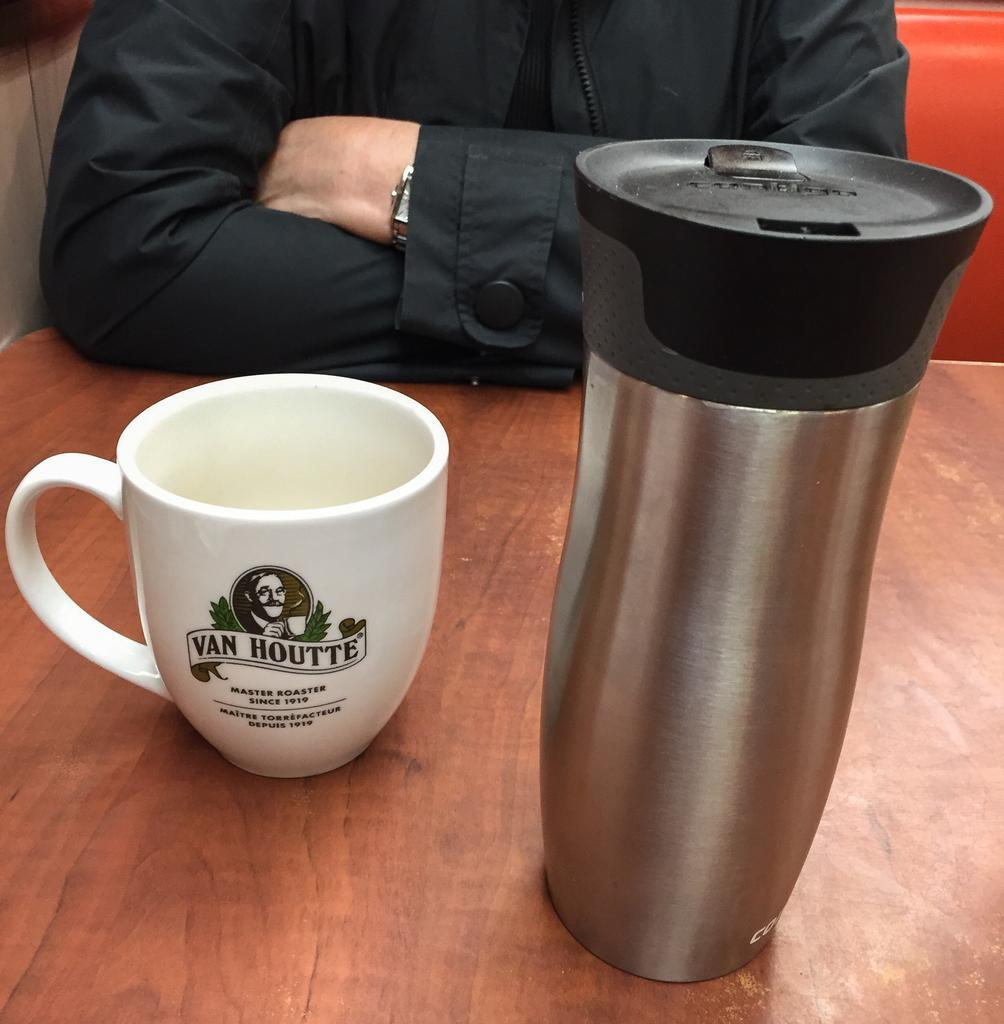What is the person in the image doing? There is a person sitting in the image. What objects are on the table in front of the person? There is a cup and a bottle on the table in front of the person. What is visible beside the person? There is a wall visible beside the person. How many pens can be seen on the table in the image? There is no pen visible on the table in the image. What type of ticket is the person holding in the image? There is no ticket present in the image. 